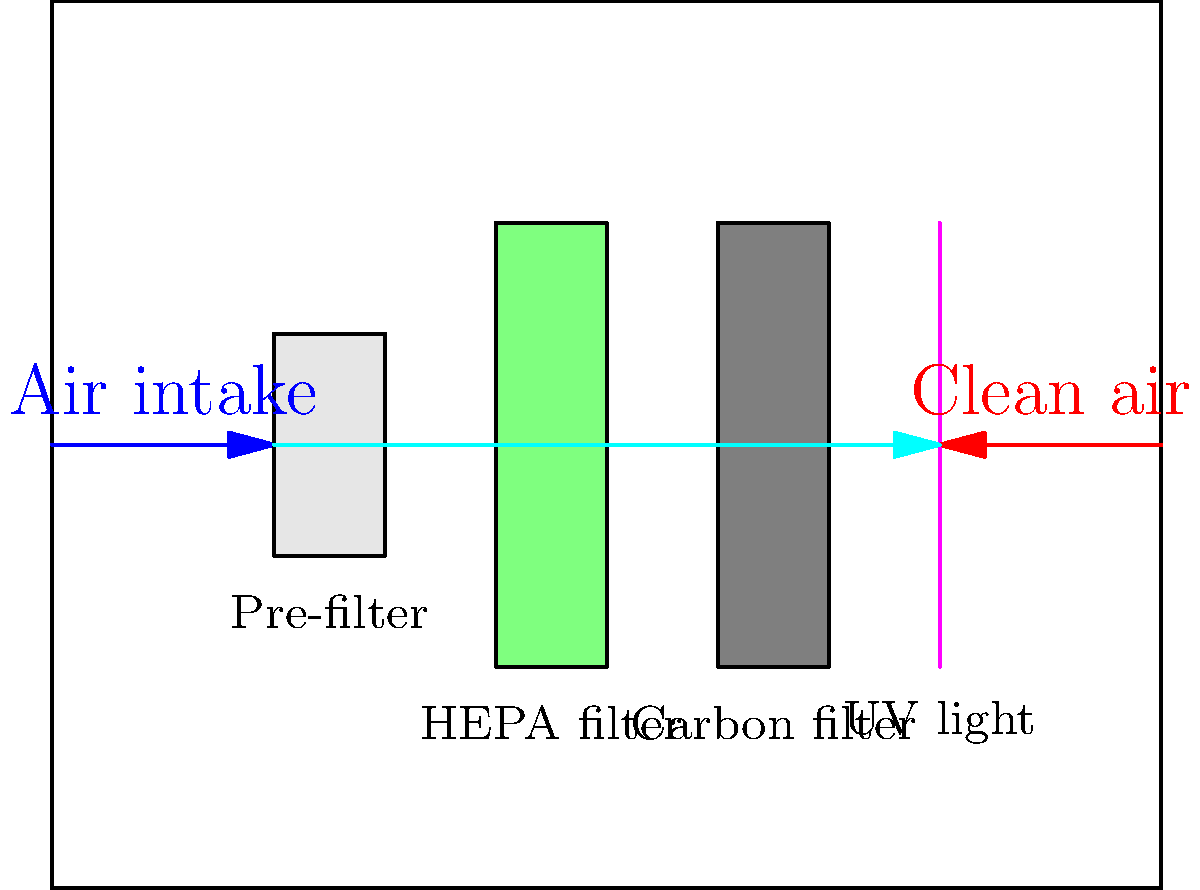In the advanced air filtration system designed for the royal chambers, what is the correct sequence of air purification components, and which component is responsible for eliminating odors and harmful gases? To answer this question, let's analyze the schematic of the advanced air filtration system:

1. Air intake: The process begins with air being drawn into the system from the left side.

2. Pre-filter: This is the first component the air passes through. It removes larger particles and debris, extending the life of subsequent filters.

3. HEPA filter: After the pre-filter, air passes through the High-Efficiency Particulate Air (HEPA) filter. This removes 99.97% of particles as small as 0.3 microns, including dust, pollen, and most bacteria.

4. Activated carbon filter: Following the HEPA filter, air moves through the activated carbon filter. This component is specifically designed to adsorb odors, volatile organic compounds (VOCs), and other harmful gases.

5. UV light: Finally, the air passes through a UV light chamber. This helps to neutralize any remaining airborne pathogens like viruses and bacteria.

6. Clean air output: The purified air is then released back into the royal chambers.

The component responsible for eliminating odors and harmful gases is the activated carbon filter. Its porous structure allows it to trap these molecular contaminants effectively.
Answer: Activated carbon filter 